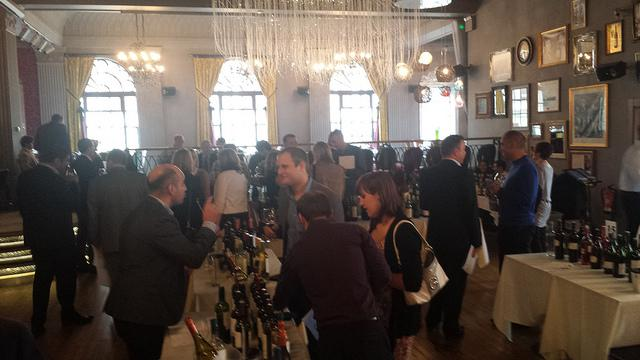New Orleans is inventor of what?

Choices:
A) beverages
B) soft drinks
C) coffee
D) cocktail cocktail 